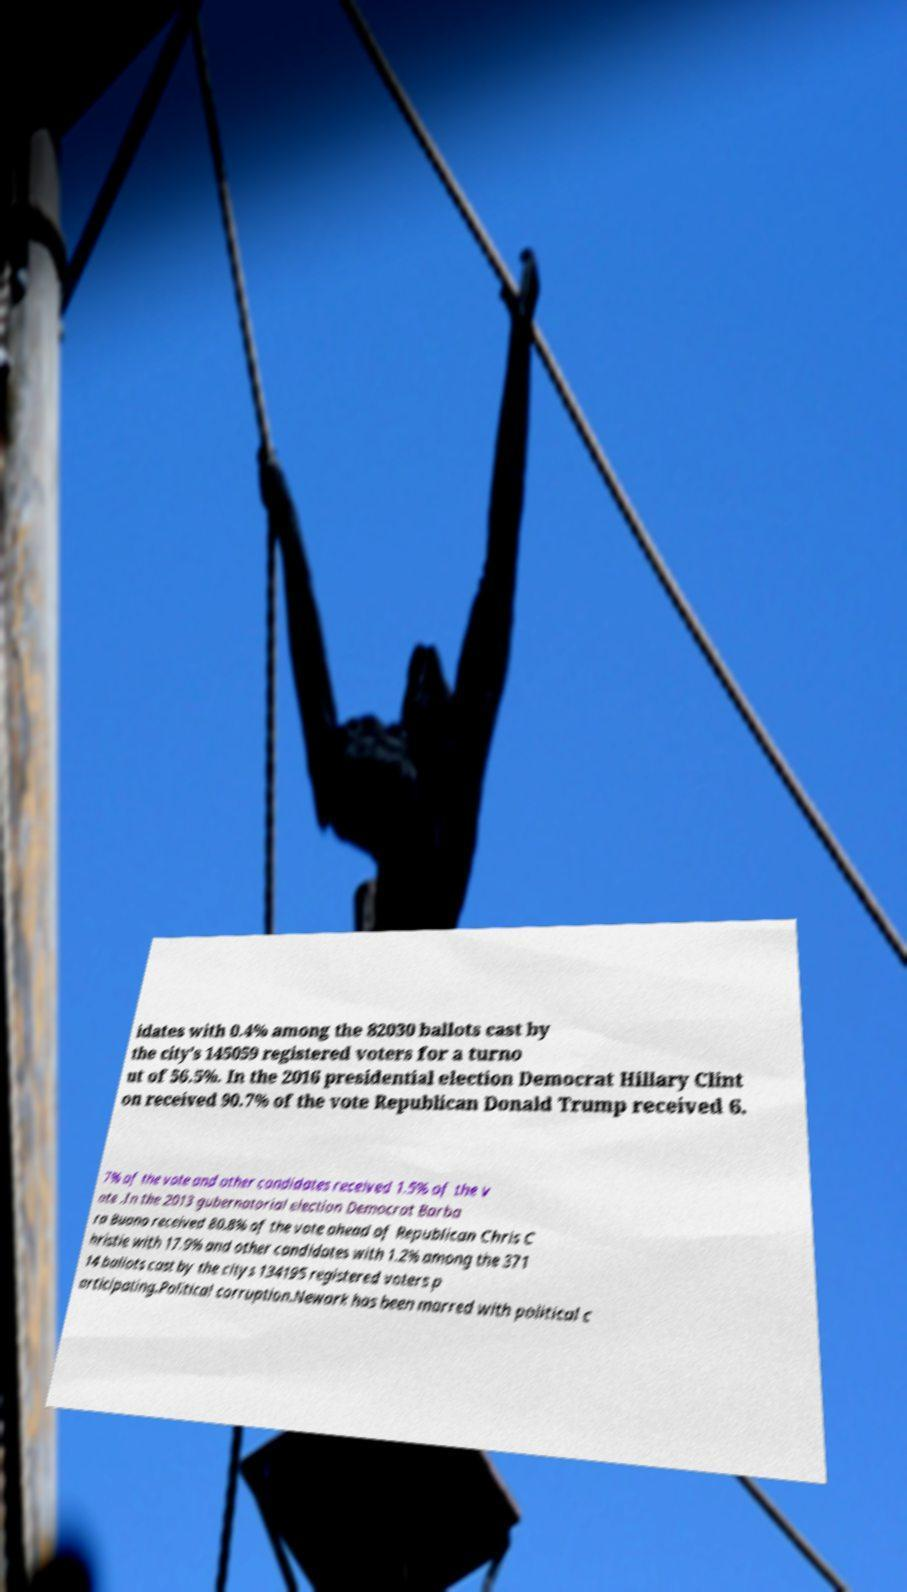Could you assist in decoding the text presented in this image and type it out clearly? idates with 0.4% among the 82030 ballots cast by the city's 145059 registered voters for a turno ut of 56.5%. In the 2016 presidential election Democrat Hillary Clint on received 90.7% of the vote Republican Donald Trump received 6. 7% of the vote and other candidates received 1.5% of the v ote .In the 2013 gubernatorial election Democrat Barba ra Buono received 80.8% of the vote ahead of Republican Chris C hristie with 17.9% and other candidates with 1.2% among the 371 14 ballots cast by the citys 134195 registered voters p articipating.Political corruption.Newark has been marred with political c 